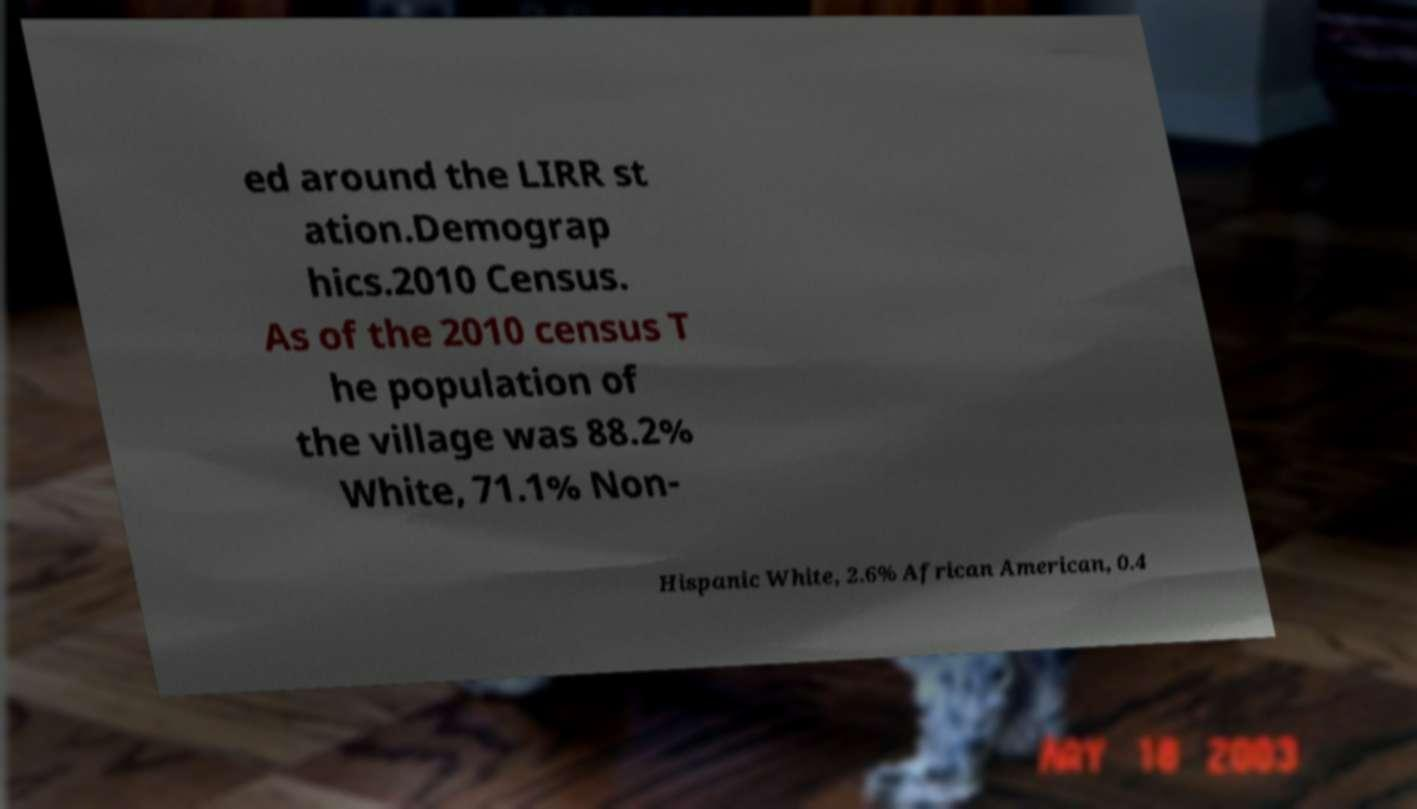Please read and relay the text visible in this image. What does it say? ed around the LIRR st ation.Demograp hics.2010 Census. As of the 2010 census T he population of the village was 88.2% White, 71.1% Non- Hispanic White, 2.6% African American, 0.4 